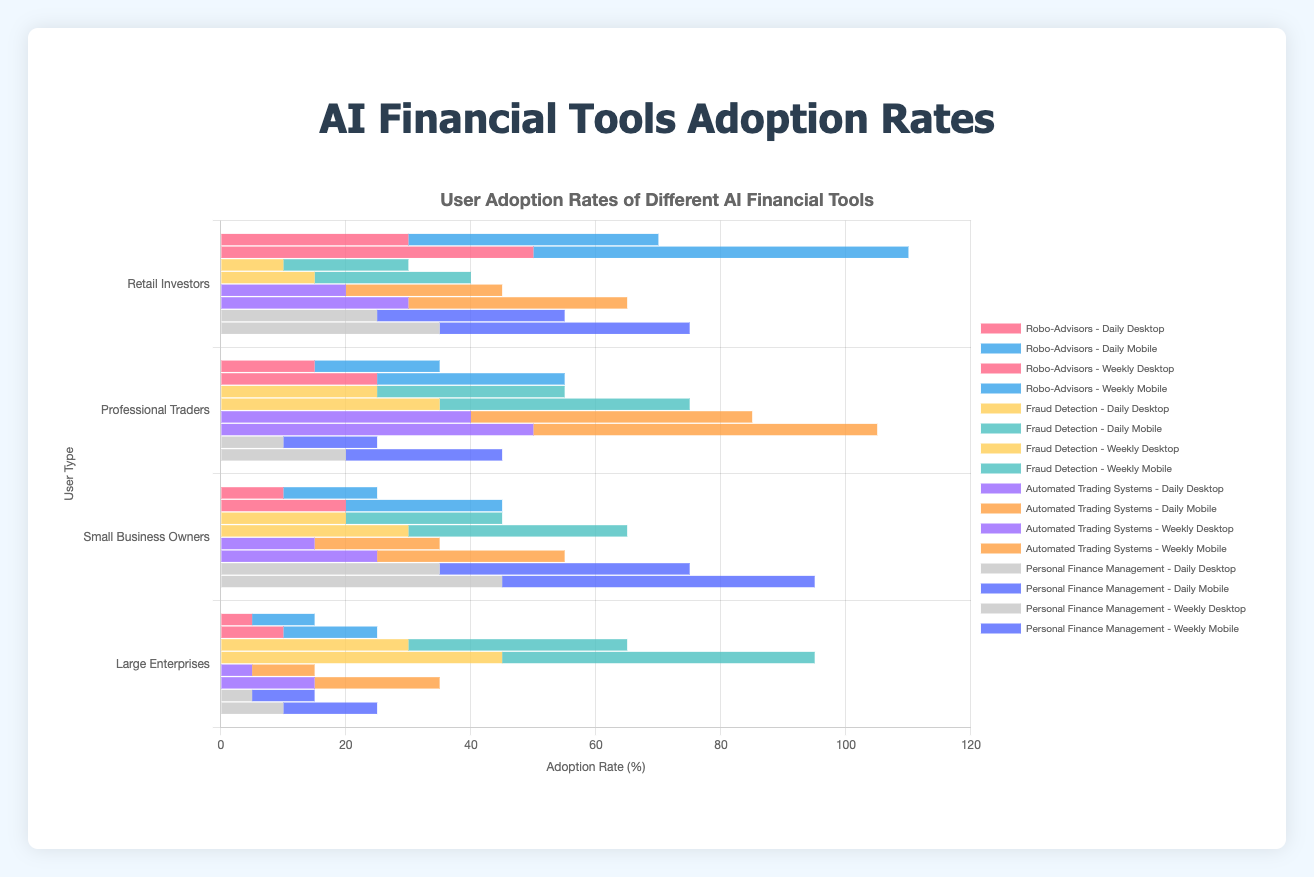What is the adoption rate of Robo-Advisors on mobile devices for Retail Investors? The adoption rate can be directly read from the figure. Look to the section labeled "Robo-Advisors", find the "Retail Investors" row, and check the value for "Mobile".
Answer: 40% Which user type has the highest adoption rate of Fraud Detection tools on a weekly basis on desktop devices? The figure shows different adoption rates for Fraud Detection tools. Identify the weekly adoption rates for each user type on desktop devices and find the highest value. Professional Traders have the highest rate at 35%.
Answer: Professional Traders For Automated Trading Systems, compare the weekly adoption rates between Professional Traders and Small Business Owners on mobile devices. Which user type has the higher adoption rate, and by how much? Check the weekly adoption rates for both Professional Traders and Small Business Owners on mobile devices in the "Automated Trading Systems" section. Professional Traders have a rate of 55%, and Small Business Owners have 30%. The difference is 55% - 30%.
Answer: Professional Traders, by 25% What is the combined daily adoption rate of Robo-Advisors and Personal Finance Management among Large Enterprises on desktop devices? Retrieve the daily adoption rates for Large Enterprises using both tools on desktop devices from their respective sections. Robo-Advisors have 5%, and Personal Finance Management has 5%. Adding these gives 5% + 5% = 10%.
Answer: 10% Compare the mobile adoption rates of Retail Investors for Fraud Detection tools on a daily frequency versus a weekly frequency. Which frequency is higher, and by how much? Look at the adoption rates for Retail Investors using mobile devices for Fraud Detection tools both daily and weekly. Daily is 20%, and weekly is 25%. The difference is 25% - 20%.
Answer: Weekly, by 5% What is the percentage difference between the daily and weekly adoption rates of Professional Traders using Automated Trading Systems on desktop devices? Identify the adoption rates for Professional Traders using Automated Trading Systems on desktop devices both daily and weekly. Daily is 40%, and weekly is 50%. The percentage difference is obtained by ((50% - 40%) / 40%) * 100 = 25%.
Answer: 25% Among Small Business Owners, which AI Financial Tool has the highest overall adoption rate (combining daily and weekly frequencies) on mobile devices? Sum the daily and weekly mobile adoption rates for Small Business Owners across all tools, and identify the highest total. Robo-Advisors: 15% + 25% = 40%, Fraud Detection: 25% + 35% = 60%, Automated Trading Systems: 20% + 30% = 50%, Personal Finance Management: 40% + 50% = 90%. Personal Finance Management has the highest combined rate.
Answer: Personal Finance Management What is the visual difference in the bar lengths representing daily mobile usage for Robo-Advisors between Retail Investors and Professional Traders? Visually inspect the bar lengths for Retail Investors and Professional Traders under "Robo-Advisors" for daily mobile usage. The Retail Investors bar is longer (40% vs 20%).
Answer: Retail Investors have a longer bar What is the average adoption rate of Professional Traders for Fraud Detection tools across all devices and frequencies? Calculate the average by summing all relevant adoption rates for Professional Traders and dividing by the number of rates. (25% + 30% + 35% + 40%) / 4 = 32.5%
Answer: 32.5% How does the weekly desktop adoption rate for Personal Finance Management among Small Business Owners compare to that of Large Enterprises? Check the weekly desktop adoption rate for Personal Finance Management among Small Business Owners and Large Enterprises. Small Business Owners have 45%, and Large Enterprises have 10%.
Answer: Higher for Small Business Owners 